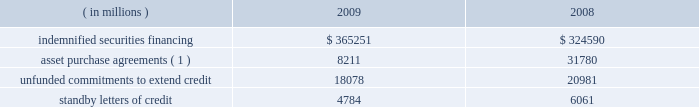Note 10 .
Commitments and contingencies credit-related commitments and contingencies : credit-related financial instruments , which are off-balance sheet , include indemnified securities financing , unfunded commitments to extend credit or purchase assets , and standby letters of credit .
The potential loss associated with indemnified securities financing , unfunded commitments and standby letters of credit is equal to the total gross contractual amount , which does not consider the value of any collateral .
The table summarizes the total gross contractual amounts of credit-related off-balance sheet financial instruments at december 31 .
Amounts reported do not reflect participations to independent third parties. .
( 1 ) amount for 2009 excludes agreements related to the commercial paper conduits , which were consolidated in may 2009 ; see note 11 .
Approximately 81% ( 81 % ) of the unfunded commitments to extend credit expire within one year from the date of issue .
Since many of these commitments are expected to expire or renew without being drawn upon , the total commitment amount does not necessarily represent future cash requirements .
Securities finance : on behalf of our customers , we lend their securities to creditworthy brokers and other institutions .
We generally indemnify our customers for the fair market value of those securities against a failure of the borrower to return such securities .
Collateral funds received in connection with our securities finance services are held by us as agent and are not recorded in our consolidated statement of condition .
We require the borrowers to provide collateral in an amount equal to or in excess of 100% ( 100 % ) of the fair market value of the securities borrowed .
The borrowed securities are revalued daily to determine if additional collateral is necessary .
In this regard , we held , as agent , cash and u.s .
Government securities with an aggregate fair value of $ 375.92 billion and $ 333.07 billion as collateral for indemnified securities on loan at december 31 , 2009 and 2008 , respectively , presented in the table above .
The collateral held by us is invested on behalf of our customers in accordance with their guidelines .
In certain cases , the collateral is invested in third-party repurchase agreements , for which we indemnify the customer against loss of the principal invested .
We require the repurchase agreement counterparty to provide collateral in an amount equal to or in excess of 100% ( 100 % ) of the amount of the repurchase agreement .
The indemnified repurchase agreements and the related collateral are not recorded in our consolidated statement of condition .
Of the collateral of $ 375.92 billion at december 31 , 2009 and $ 333.07 billion at december 31 , 2008 referenced above , $ 77.73 billion at december 31 , 2009 and $ 68.37 billion at december 31 , 2008 was invested in indemnified repurchase agreements .
We held , as agent , cash and securities with an aggregate fair value of $ 82.62 billion and $ 71.87 billion as collateral for indemnified investments in repurchase agreements at december 31 , 2009 and december 31 , 2008 , respectively .
Legal proceedings : in the ordinary course of business , we and our subsidiaries are involved in disputes , litigation and regulatory inquiries and investigations , both pending and threatened .
These matters , if resolved adversely against us , may result in monetary damages , fines and penalties or require changes in our business practices .
The resolution of these proceedings is inherently difficult to predict .
However , we do not believe that the amount of any judgment , settlement or other action arising from any pending proceeding will have a material adverse effect on our consolidated financial condition , although the outcome of certain of the matters described below may have a material adverse effect on our consolidated results of operations for the period in which such matter is resolved .
What is the percentage change in the standby letters of credit from 2008 to 2009? 
Computations: ((4784 - 6061) / 6061)
Answer: -0.21069. Note 10 .
Commitments and contingencies credit-related commitments and contingencies : credit-related financial instruments , which are off-balance sheet , include indemnified securities financing , unfunded commitments to extend credit or purchase assets , and standby letters of credit .
The potential loss associated with indemnified securities financing , unfunded commitments and standby letters of credit is equal to the total gross contractual amount , which does not consider the value of any collateral .
The table summarizes the total gross contractual amounts of credit-related off-balance sheet financial instruments at december 31 .
Amounts reported do not reflect participations to independent third parties. .
( 1 ) amount for 2009 excludes agreements related to the commercial paper conduits , which were consolidated in may 2009 ; see note 11 .
Approximately 81% ( 81 % ) of the unfunded commitments to extend credit expire within one year from the date of issue .
Since many of these commitments are expected to expire or renew without being drawn upon , the total commitment amount does not necessarily represent future cash requirements .
Securities finance : on behalf of our customers , we lend their securities to creditworthy brokers and other institutions .
We generally indemnify our customers for the fair market value of those securities against a failure of the borrower to return such securities .
Collateral funds received in connection with our securities finance services are held by us as agent and are not recorded in our consolidated statement of condition .
We require the borrowers to provide collateral in an amount equal to or in excess of 100% ( 100 % ) of the fair market value of the securities borrowed .
The borrowed securities are revalued daily to determine if additional collateral is necessary .
In this regard , we held , as agent , cash and u.s .
Government securities with an aggregate fair value of $ 375.92 billion and $ 333.07 billion as collateral for indemnified securities on loan at december 31 , 2009 and 2008 , respectively , presented in the table above .
The collateral held by us is invested on behalf of our customers in accordance with their guidelines .
In certain cases , the collateral is invested in third-party repurchase agreements , for which we indemnify the customer against loss of the principal invested .
We require the repurchase agreement counterparty to provide collateral in an amount equal to or in excess of 100% ( 100 % ) of the amount of the repurchase agreement .
The indemnified repurchase agreements and the related collateral are not recorded in our consolidated statement of condition .
Of the collateral of $ 375.92 billion at december 31 , 2009 and $ 333.07 billion at december 31 , 2008 referenced above , $ 77.73 billion at december 31 , 2009 and $ 68.37 billion at december 31 , 2008 was invested in indemnified repurchase agreements .
We held , as agent , cash and securities with an aggregate fair value of $ 82.62 billion and $ 71.87 billion as collateral for indemnified investments in repurchase agreements at december 31 , 2009 and december 31 , 2008 , respectively .
Legal proceedings : in the ordinary course of business , we and our subsidiaries are involved in disputes , litigation and regulatory inquiries and investigations , both pending and threatened .
These matters , if resolved adversely against us , may result in monetary damages , fines and penalties or require changes in our business practices .
The resolution of these proceedings is inherently difficult to predict .
However , we do not believe that the amount of any judgment , settlement or other action arising from any pending proceeding will have a material adverse effect on our consolidated financial condition , although the outcome of certain of the matters described below may have a material adverse effect on our consolidated results of operations for the period in which such matter is resolved .
What is the percentage change in the indemnified securities financing from 2008 to 2009? 
Computations: ((365251 - 324590) / 324590)
Answer: 0.12527. Note 10 .
Commitments and contingencies credit-related commitments and contingencies : credit-related financial instruments , which are off-balance sheet , include indemnified securities financing , unfunded commitments to extend credit or purchase assets , and standby letters of credit .
The potential loss associated with indemnified securities financing , unfunded commitments and standby letters of credit is equal to the total gross contractual amount , which does not consider the value of any collateral .
The table summarizes the total gross contractual amounts of credit-related off-balance sheet financial instruments at december 31 .
Amounts reported do not reflect participations to independent third parties. .
( 1 ) amount for 2009 excludes agreements related to the commercial paper conduits , which were consolidated in may 2009 ; see note 11 .
Approximately 81% ( 81 % ) of the unfunded commitments to extend credit expire within one year from the date of issue .
Since many of these commitments are expected to expire or renew without being drawn upon , the total commitment amount does not necessarily represent future cash requirements .
Securities finance : on behalf of our customers , we lend their securities to creditworthy brokers and other institutions .
We generally indemnify our customers for the fair market value of those securities against a failure of the borrower to return such securities .
Collateral funds received in connection with our securities finance services are held by us as agent and are not recorded in our consolidated statement of condition .
We require the borrowers to provide collateral in an amount equal to or in excess of 100% ( 100 % ) of the fair market value of the securities borrowed .
The borrowed securities are revalued daily to determine if additional collateral is necessary .
In this regard , we held , as agent , cash and u.s .
Government securities with an aggregate fair value of $ 375.92 billion and $ 333.07 billion as collateral for indemnified securities on loan at december 31 , 2009 and 2008 , respectively , presented in the table above .
The collateral held by us is invested on behalf of our customers in accordance with their guidelines .
In certain cases , the collateral is invested in third-party repurchase agreements , for which we indemnify the customer against loss of the principal invested .
We require the repurchase agreement counterparty to provide collateral in an amount equal to or in excess of 100% ( 100 % ) of the amount of the repurchase agreement .
The indemnified repurchase agreements and the related collateral are not recorded in our consolidated statement of condition .
Of the collateral of $ 375.92 billion at december 31 , 2009 and $ 333.07 billion at december 31 , 2008 referenced above , $ 77.73 billion at december 31 , 2009 and $ 68.37 billion at december 31 , 2008 was invested in indemnified repurchase agreements .
We held , as agent , cash and securities with an aggregate fair value of $ 82.62 billion and $ 71.87 billion as collateral for indemnified investments in repurchase agreements at december 31 , 2009 and december 31 , 2008 , respectively .
Legal proceedings : in the ordinary course of business , we and our subsidiaries are involved in disputes , litigation and regulatory inquiries and investigations , both pending and threatened .
These matters , if resolved adversely against us , may result in monetary damages , fines and penalties or require changes in our business practices .
The resolution of these proceedings is inherently difficult to predict .
However , we do not believe that the amount of any judgment , settlement or other action arising from any pending proceeding will have a material adverse effect on our consolidated financial condition , although the outcome of certain of the matters described below may have a material adverse effect on our consolidated results of operations for the period in which such matter is resolved .
What is the percent change in asset purchase agreements between 2008 and 2009? 
Computations: ((8211 - 31780) / 31780)
Answer: -0.74163. 